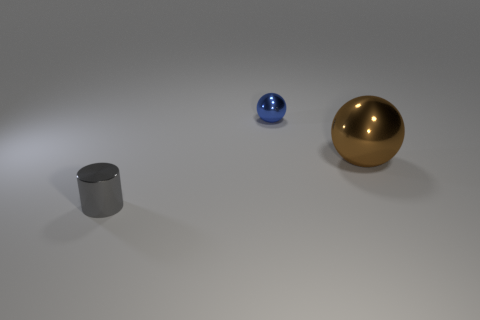Add 3 blocks. How many objects exist? 6 Subtract all cylinders. How many objects are left? 2 Add 1 brown metal balls. How many brown metal balls are left? 2 Add 1 small yellow rubber cylinders. How many small yellow rubber cylinders exist? 1 Subtract 0 blue cylinders. How many objects are left? 3 Subtract all big metallic spheres. Subtract all small spheres. How many objects are left? 1 